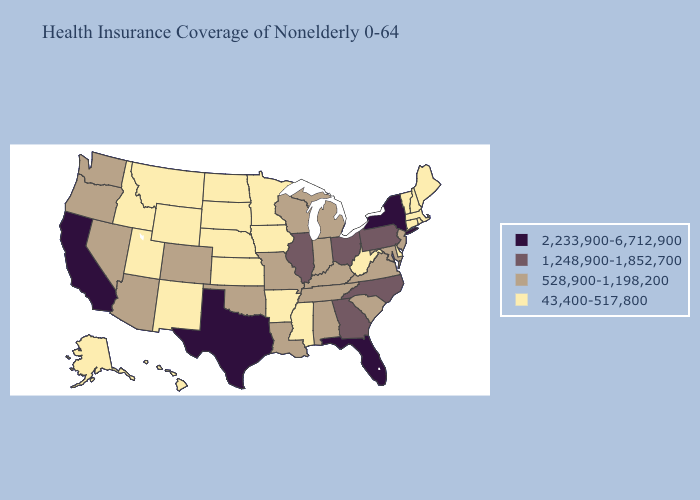Among the states that border Tennessee , which have the lowest value?
Write a very short answer. Arkansas, Mississippi. What is the lowest value in states that border Michigan?
Be succinct. 528,900-1,198,200. Does Mississippi have the same value as New York?
Short answer required. No. Name the states that have a value in the range 1,248,900-1,852,700?
Short answer required. Georgia, Illinois, North Carolina, Ohio, Pennsylvania. Among the states that border Wyoming , which have the lowest value?
Write a very short answer. Idaho, Montana, Nebraska, South Dakota, Utah. What is the value of Alabama?
Concise answer only. 528,900-1,198,200. Among the states that border Louisiana , which have the highest value?
Short answer required. Texas. Name the states that have a value in the range 1,248,900-1,852,700?
Short answer required. Georgia, Illinois, North Carolina, Ohio, Pennsylvania. Name the states that have a value in the range 2,233,900-6,712,900?
Keep it brief. California, Florida, New York, Texas. Does the map have missing data?
Give a very brief answer. No. What is the value of Florida?
Short answer required. 2,233,900-6,712,900. What is the value of Texas?
Quick response, please. 2,233,900-6,712,900. How many symbols are there in the legend?
Keep it brief. 4. Among the states that border Iowa , which have the lowest value?
Short answer required. Minnesota, Nebraska, South Dakota. Name the states that have a value in the range 1,248,900-1,852,700?
Write a very short answer. Georgia, Illinois, North Carolina, Ohio, Pennsylvania. 